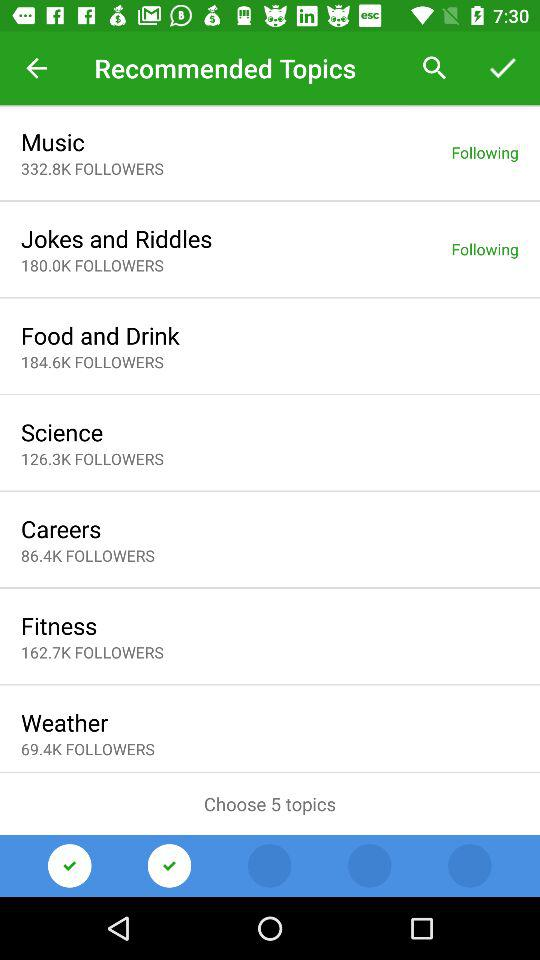Which topic has the least number of followers?
Answer the question using a single word or phrase. Weather 